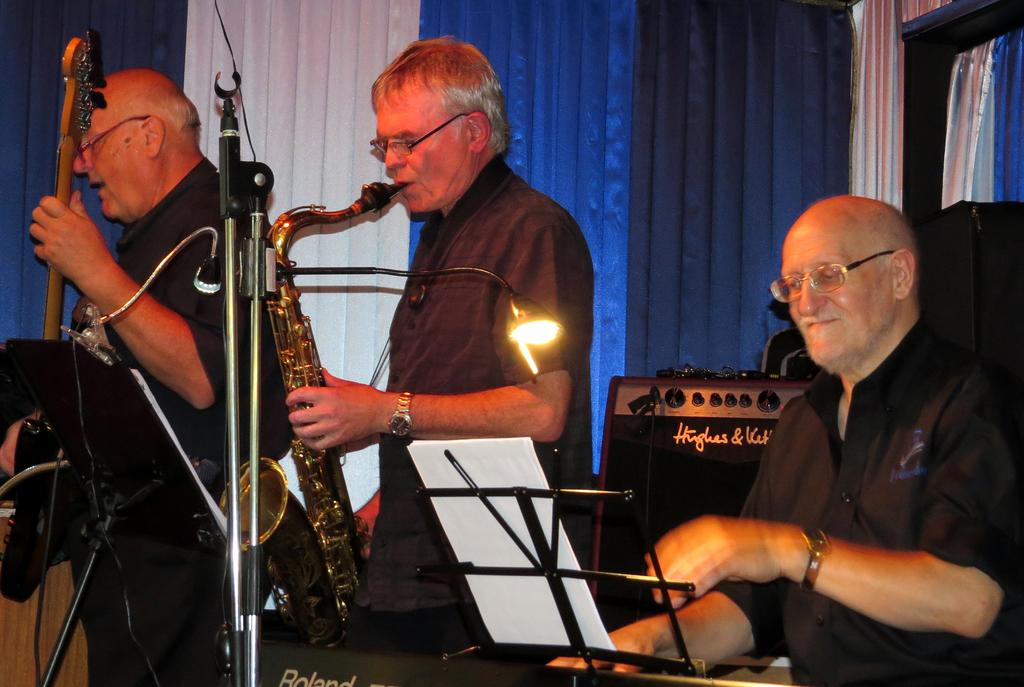What are the musicians in the image doing? The musicians in the image are playing musical instruments. What can be seen in the background of the image? There are colorful curtains in the background of the image. How does the audience show their respect for the musicians in the image? There is no audience present in the image, so it is not possible to determine how they might show respect for the musicians. 